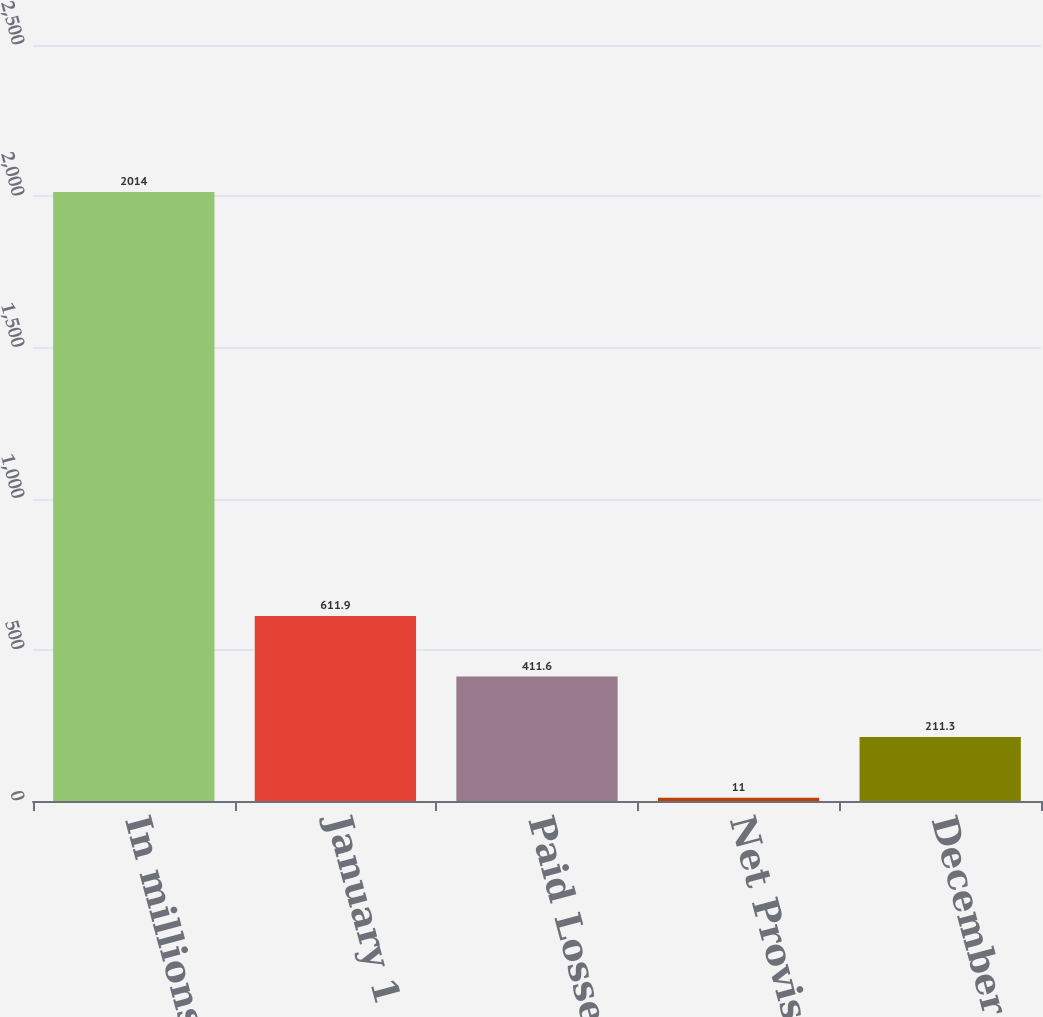Convert chart. <chart><loc_0><loc_0><loc_500><loc_500><bar_chart><fcel>In millions<fcel>January 1<fcel>Paid Losses<fcel>Net Provision<fcel>December 31<nl><fcel>2014<fcel>611.9<fcel>411.6<fcel>11<fcel>211.3<nl></chart> 